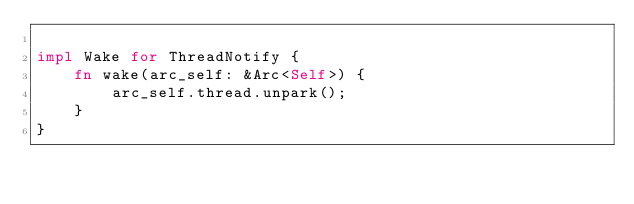<code> <loc_0><loc_0><loc_500><loc_500><_Rust_>
impl Wake for ThreadNotify {
    fn wake(arc_self: &Arc<Self>) {
        arc_self.thread.unpark();
    }
}
</code> 